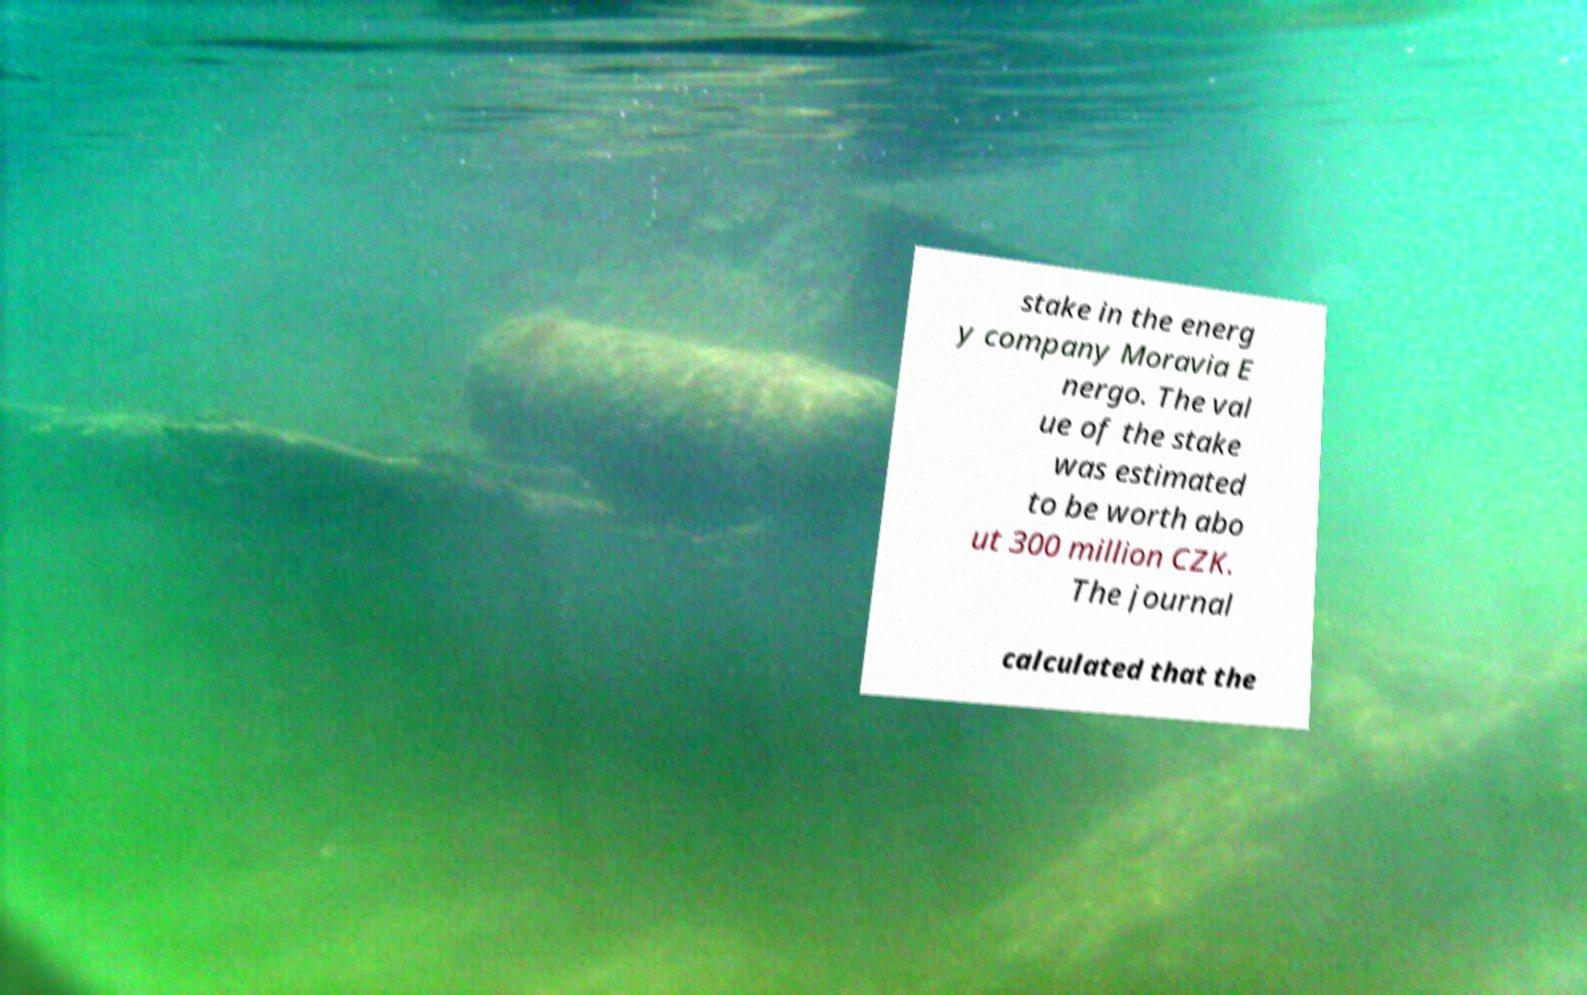Please read and relay the text visible in this image. What does it say? stake in the energ y company Moravia E nergo. The val ue of the stake was estimated to be worth abo ut 300 million CZK. The journal calculated that the 